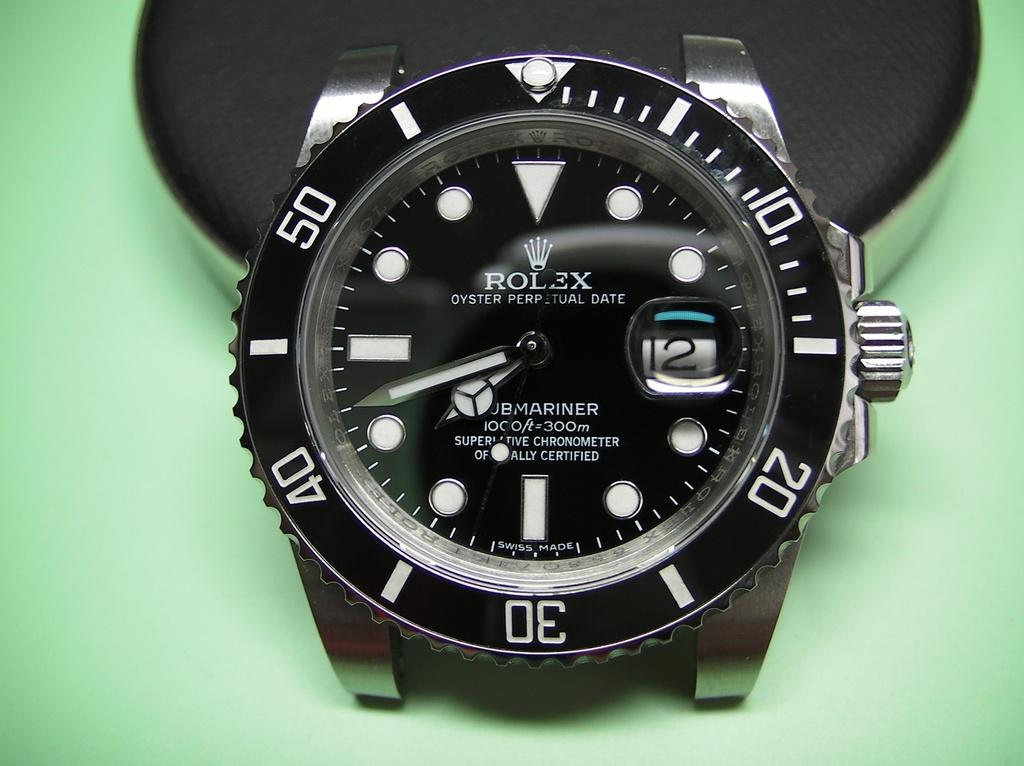<image>
Give a short and clear explanation of the subsequent image. A black face Rolex watch with white numbers that has no wristband. 